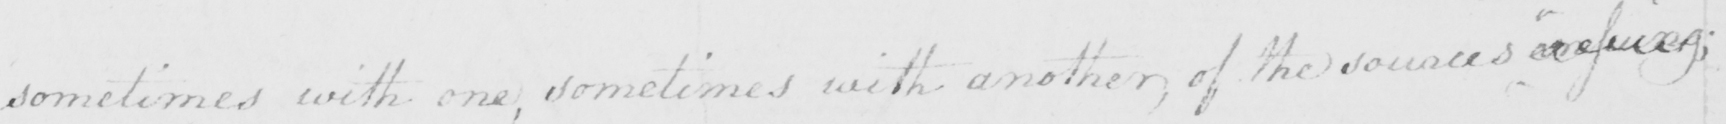Transcribe the text shown in this historical manuscript line. sometimes with one , sometimes with another , of the sources ensuing ; 